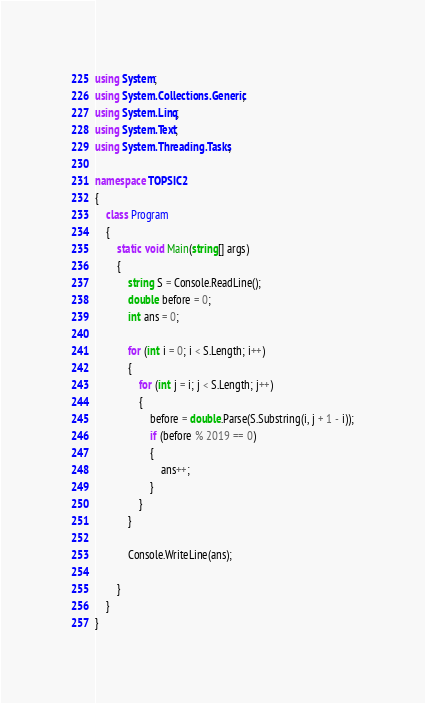<code> <loc_0><loc_0><loc_500><loc_500><_C#_>using System;
using System.Collections.Generic;
using System.Linq;
using System.Text;
using System.Threading.Tasks;

namespace TOPSIC2
{
    class Program
    {
        static void Main(string[] args)
        {
            string S = Console.ReadLine();
            double before = 0;
            int ans = 0;

            for (int i = 0; i < S.Length; i++)
            {
                for (int j = i; j < S.Length; j++)
                {
                    before = double.Parse(S.Substring(i, j + 1 - i));
                    if (before % 2019 == 0)
                    {
                        ans++;
                    }
                }
            }

            Console.WriteLine(ans);

        }
    }
}
</code> 